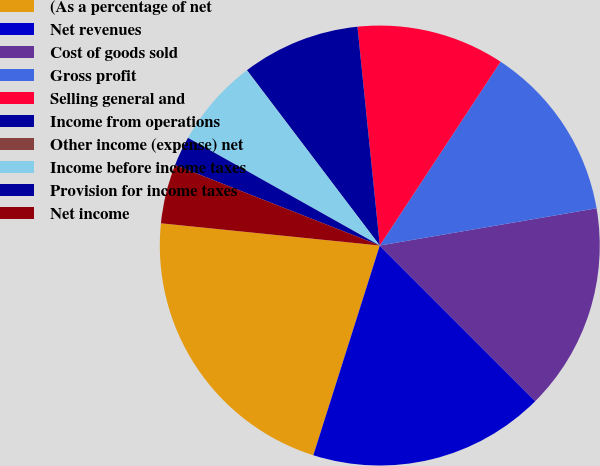<chart> <loc_0><loc_0><loc_500><loc_500><pie_chart><fcel>(As a percentage of net<fcel>Net revenues<fcel>Cost of goods sold<fcel>Gross profit<fcel>Selling general and<fcel>Income from operations<fcel>Other income (expense) net<fcel>Income before income taxes<fcel>Provision for income taxes<fcel>Net income<nl><fcel>21.73%<fcel>17.38%<fcel>15.21%<fcel>13.04%<fcel>10.87%<fcel>8.7%<fcel>0.01%<fcel>6.53%<fcel>2.18%<fcel>4.35%<nl></chart> 